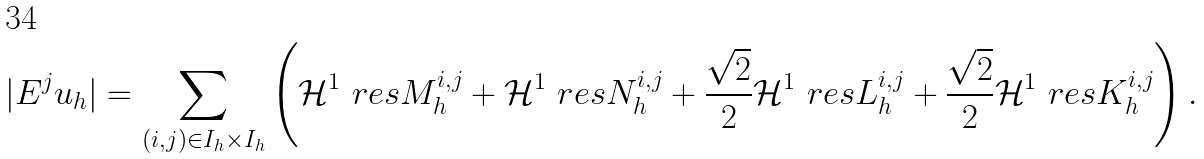<formula> <loc_0><loc_0><loc_500><loc_500>| E ^ { j } u _ { h } | = \sum _ { ( i , j ) \in I _ { h } \times I _ { h } } \left ( \mathcal { H } ^ { 1 } \ r e s M ^ { i , j } _ { h } + \mathcal { H } ^ { 1 } \ r e s N ^ { i , j } _ { h } + \frac { \sqrt { 2 } } { 2 } \mathcal { H } ^ { 1 } \ r e s L ^ { i , j } _ { h } + \frac { \sqrt { 2 } } { 2 } \mathcal { H } ^ { 1 } \ r e s K ^ { i , j } _ { h } \right ) .</formula> 